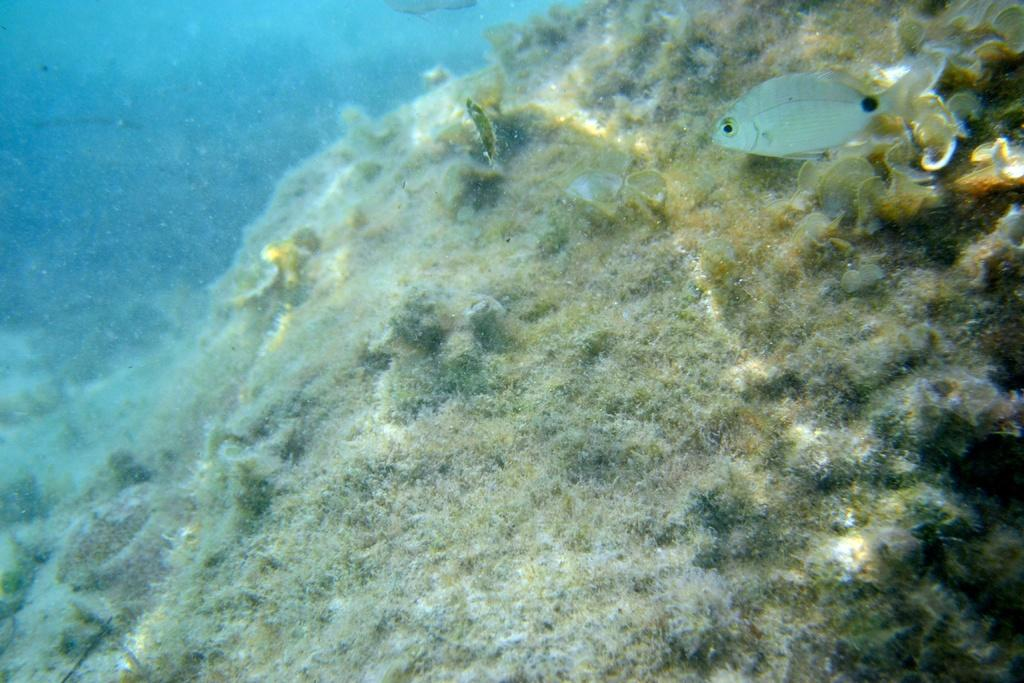What type of animal is present in the image? There is a fish in the image. What else can be seen in the image besides the fish? There are marine plants in the image. What color dominates the image? The image has a blue color in this part. What type of selection process is being used by the fish in the image? There is no indication in the image that the fish is involved in a selection process. Can you see the tail of the fish in the image? The image does not show the tail of the fish, as only a part of the fish is visible. 